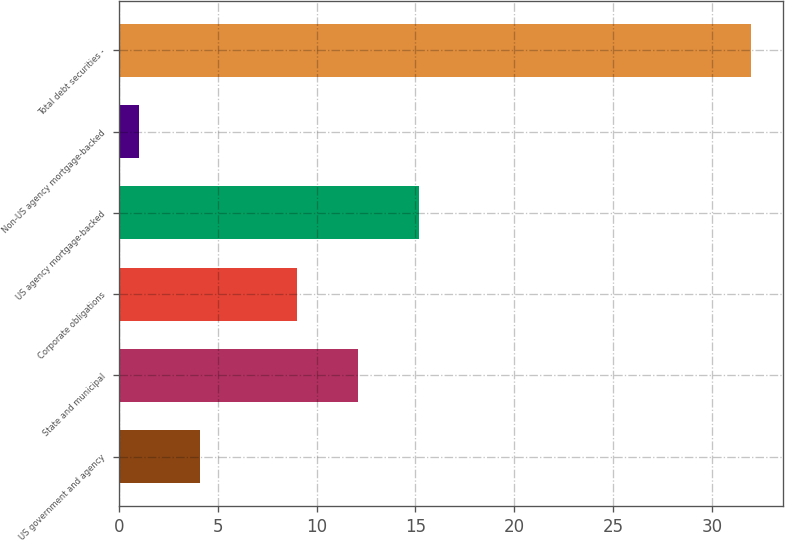Convert chart. <chart><loc_0><loc_0><loc_500><loc_500><bar_chart><fcel>US government and agency<fcel>State and municipal<fcel>Corporate obligations<fcel>US agency mortgage-backed<fcel>Non-US agency mortgage-backed<fcel>Total debt securities -<nl><fcel>4.1<fcel>12.1<fcel>9<fcel>15.2<fcel>1<fcel>32<nl></chart> 